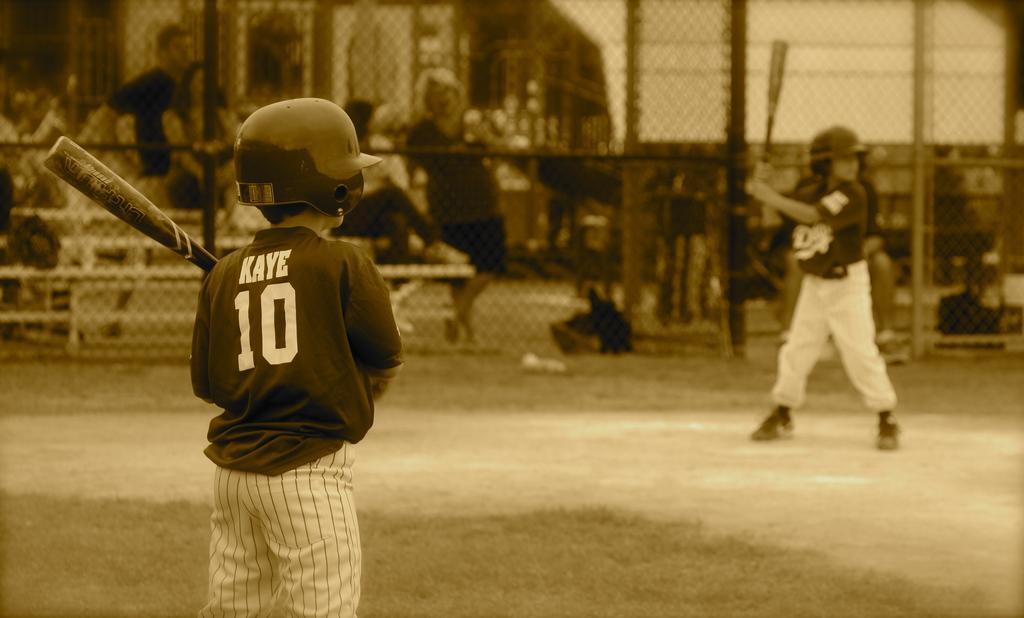Please provide a concise description of this image. In this image in the front there is a person standing and holding a baseball bat in his hand and wearing a helmet. In the background there is a person standing and playing and there is a fence and behind the fence, there are persons sitting and standing. 